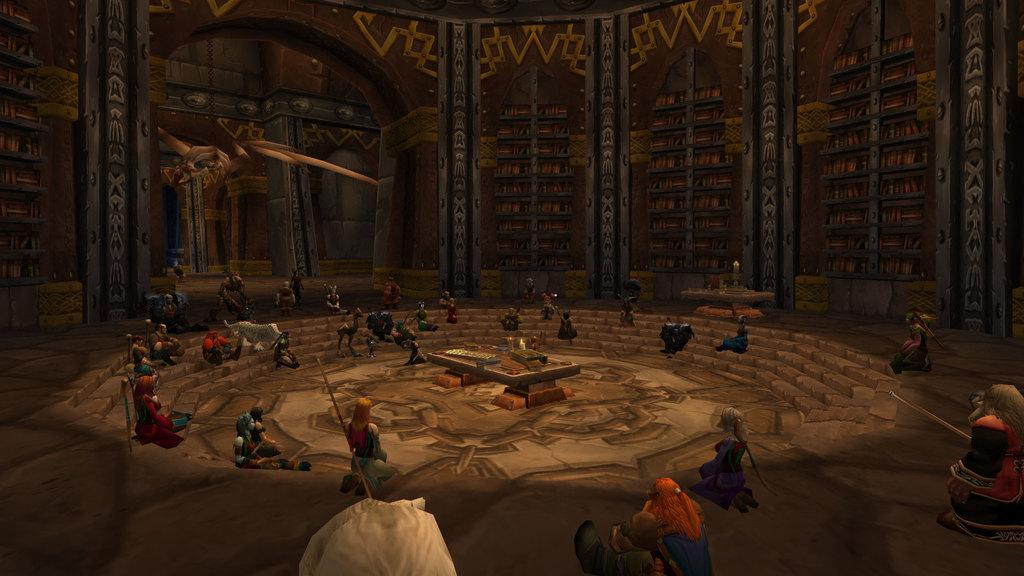What type of image is being described? The image is animated. What is the setting of the image? The image depicts the inside view of a room. Are there any people in the room? Yes, there are persons in the room. What is one of the features of the room? There is a wall in the room. What else can be found in the room? There are objects in the room. What type of cough can be heard from the persons in the image? There is no sound in the image, so it is not possible to determine if any coughs can be heard. 